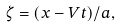Convert formula to latex. <formula><loc_0><loc_0><loc_500><loc_500>\zeta = ( x - V t ) / a ,</formula> 